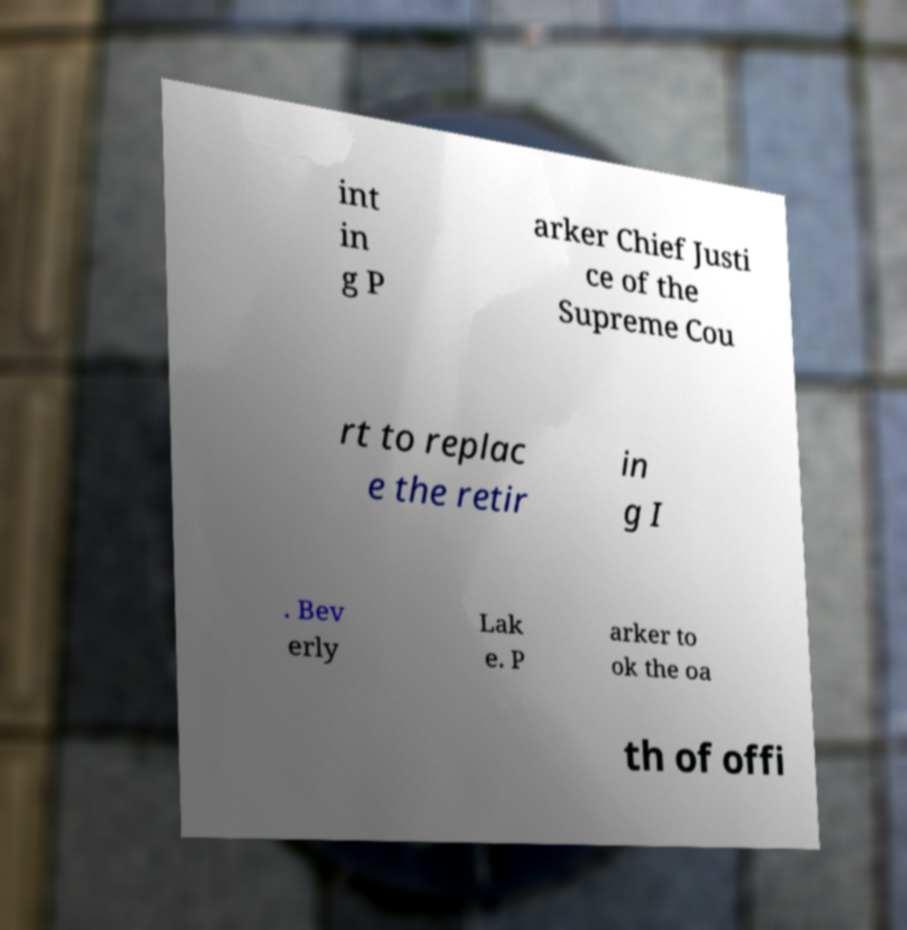Could you assist in decoding the text presented in this image and type it out clearly? int in g P arker Chief Justi ce of the Supreme Cou rt to replac e the retir in g I . Bev erly Lak e. P arker to ok the oa th of offi 